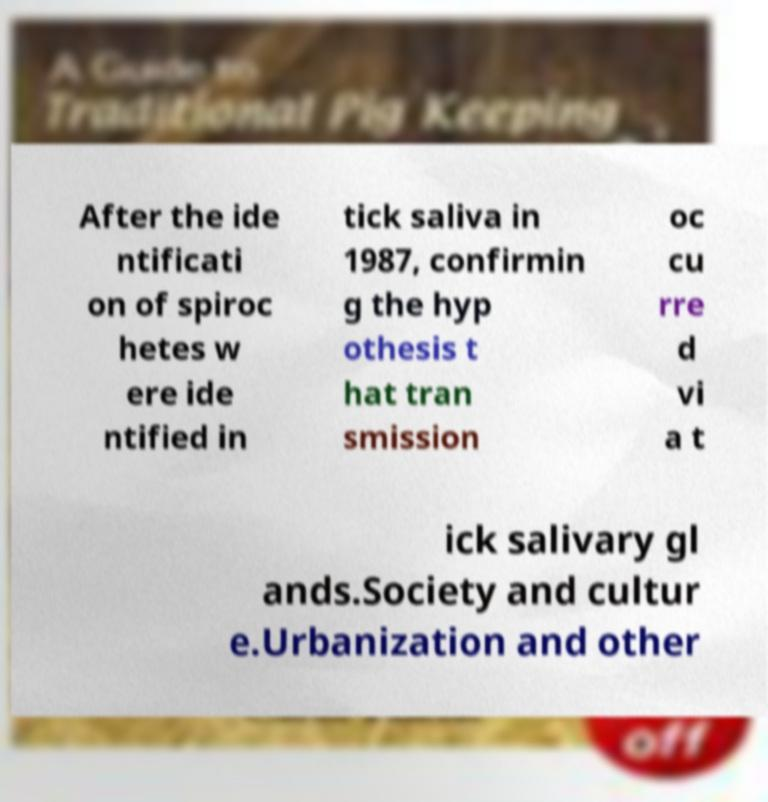For documentation purposes, I need the text within this image transcribed. Could you provide that? After the ide ntificati on of spiroc hetes w ere ide ntified in tick saliva in 1987, confirmin g the hyp othesis t hat tran smission oc cu rre d vi a t ick salivary gl ands.Society and cultur e.Urbanization and other 